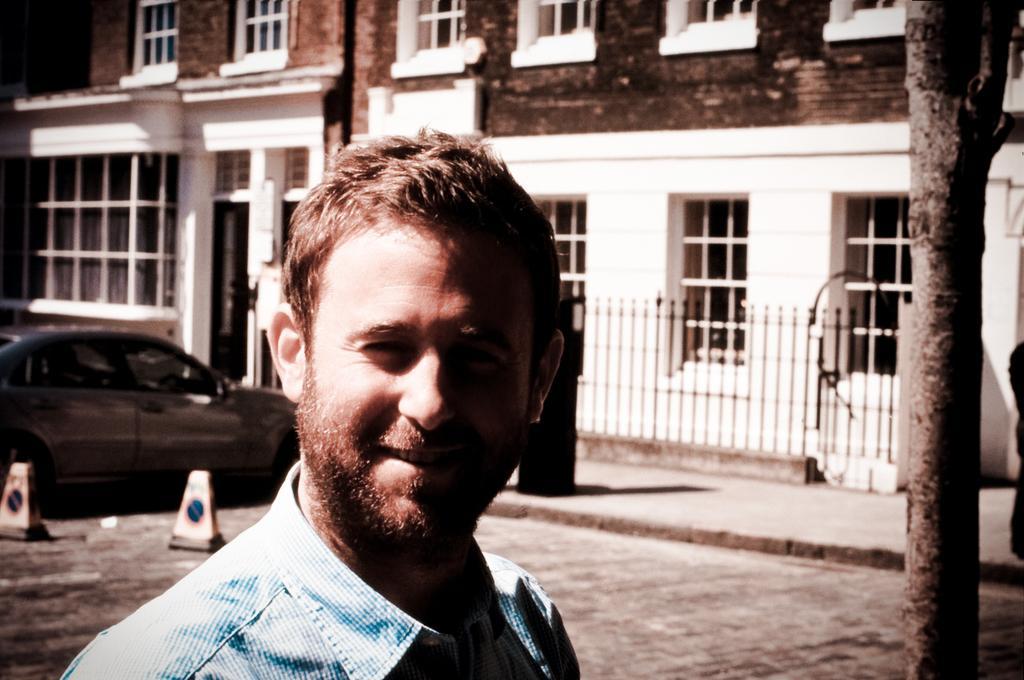Describe this image in one or two sentences. In this image, we can see a man smiling and in the background, there are traffic cones, a car, building and a tree. 